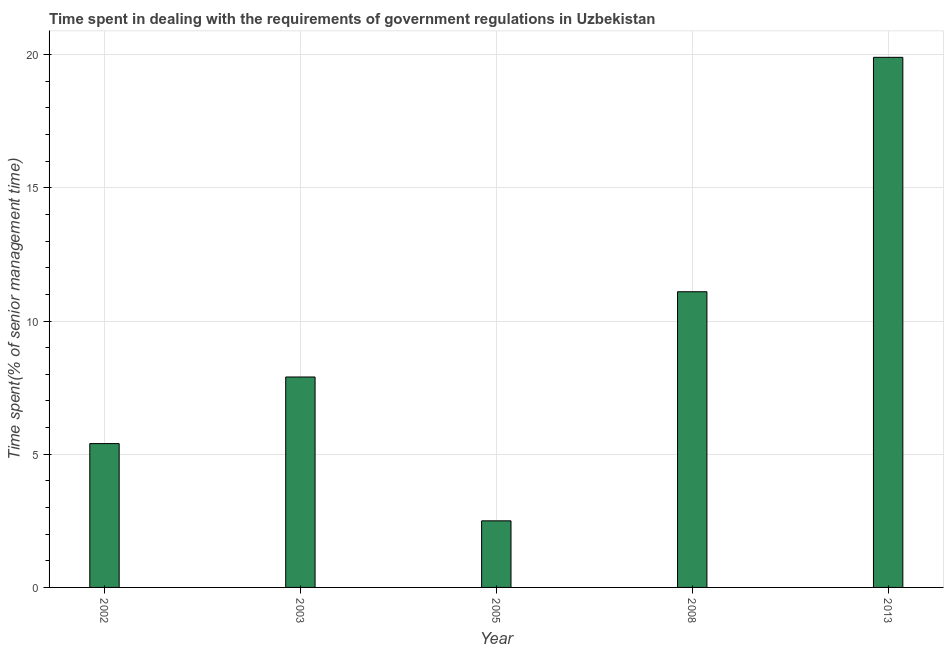Does the graph contain grids?
Ensure brevity in your answer.  Yes. What is the title of the graph?
Your answer should be compact. Time spent in dealing with the requirements of government regulations in Uzbekistan. What is the label or title of the Y-axis?
Provide a succinct answer. Time spent(% of senior management time). Across all years, what is the maximum time spent in dealing with government regulations?
Offer a terse response. 19.9. Across all years, what is the minimum time spent in dealing with government regulations?
Your answer should be very brief. 2.5. What is the sum of the time spent in dealing with government regulations?
Offer a terse response. 46.8. What is the difference between the time spent in dealing with government regulations in 2005 and 2008?
Make the answer very short. -8.6. What is the average time spent in dealing with government regulations per year?
Offer a terse response. 9.36. In how many years, is the time spent in dealing with government regulations greater than 10 %?
Ensure brevity in your answer.  2. Do a majority of the years between 2003 and 2005 (inclusive) have time spent in dealing with government regulations greater than 12 %?
Offer a terse response. No. What is the ratio of the time spent in dealing with government regulations in 2005 to that in 2013?
Your response must be concise. 0.13. Is the difference between the time spent in dealing with government regulations in 2005 and 2013 greater than the difference between any two years?
Provide a succinct answer. Yes. What is the difference between the highest and the second highest time spent in dealing with government regulations?
Your response must be concise. 8.8. Is the sum of the time spent in dealing with government regulations in 2002 and 2013 greater than the maximum time spent in dealing with government regulations across all years?
Ensure brevity in your answer.  Yes. In how many years, is the time spent in dealing with government regulations greater than the average time spent in dealing with government regulations taken over all years?
Your response must be concise. 2. How many bars are there?
Offer a terse response. 5. How many years are there in the graph?
Your answer should be very brief. 5. Are the values on the major ticks of Y-axis written in scientific E-notation?
Ensure brevity in your answer.  No. What is the difference between the Time spent(% of senior management time) in 2002 and 2003?
Offer a terse response. -2.5. What is the difference between the Time spent(% of senior management time) in 2002 and 2005?
Your response must be concise. 2.9. What is the difference between the Time spent(% of senior management time) in 2002 and 2008?
Keep it short and to the point. -5.7. What is the difference between the Time spent(% of senior management time) in 2002 and 2013?
Give a very brief answer. -14.5. What is the difference between the Time spent(% of senior management time) in 2003 and 2008?
Your response must be concise. -3.2. What is the difference between the Time spent(% of senior management time) in 2003 and 2013?
Give a very brief answer. -12. What is the difference between the Time spent(% of senior management time) in 2005 and 2008?
Keep it short and to the point. -8.6. What is the difference between the Time spent(% of senior management time) in 2005 and 2013?
Give a very brief answer. -17.4. What is the ratio of the Time spent(% of senior management time) in 2002 to that in 2003?
Make the answer very short. 0.68. What is the ratio of the Time spent(% of senior management time) in 2002 to that in 2005?
Make the answer very short. 2.16. What is the ratio of the Time spent(% of senior management time) in 2002 to that in 2008?
Give a very brief answer. 0.49. What is the ratio of the Time spent(% of senior management time) in 2002 to that in 2013?
Your answer should be compact. 0.27. What is the ratio of the Time spent(% of senior management time) in 2003 to that in 2005?
Your response must be concise. 3.16. What is the ratio of the Time spent(% of senior management time) in 2003 to that in 2008?
Offer a terse response. 0.71. What is the ratio of the Time spent(% of senior management time) in 2003 to that in 2013?
Provide a short and direct response. 0.4. What is the ratio of the Time spent(% of senior management time) in 2005 to that in 2008?
Make the answer very short. 0.23. What is the ratio of the Time spent(% of senior management time) in 2005 to that in 2013?
Offer a very short reply. 0.13. What is the ratio of the Time spent(% of senior management time) in 2008 to that in 2013?
Keep it short and to the point. 0.56. 